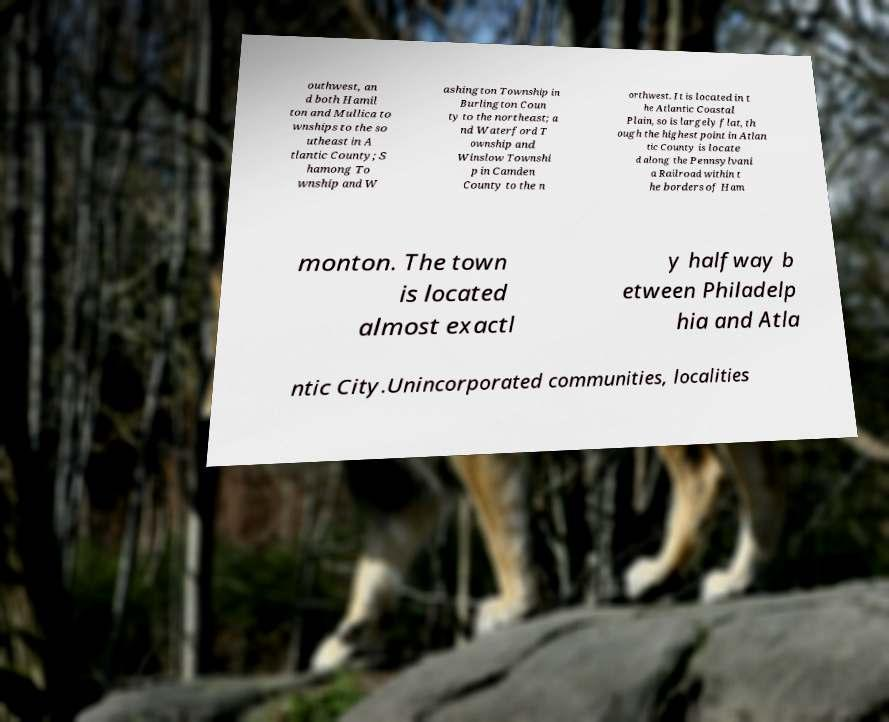Could you assist in decoding the text presented in this image and type it out clearly? outhwest, an d both Hamil ton and Mullica to wnships to the so utheast in A tlantic County; S hamong To wnship and W ashington Township in Burlington Coun ty to the northeast; a nd Waterford T ownship and Winslow Townshi p in Camden County to the n orthwest. It is located in t he Atlantic Coastal Plain, so is largely flat, th ough the highest point in Atlan tic County is locate d along the Pennsylvani a Railroad within t he borders of Ham monton. The town is located almost exactl y halfway b etween Philadelp hia and Atla ntic City.Unincorporated communities, localities 